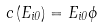<formula> <loc_0><loc_0><loc_500><loc_500>c \left ( E _ { i 0 } \right ) = E _ { i 0 } \phi</formula> 